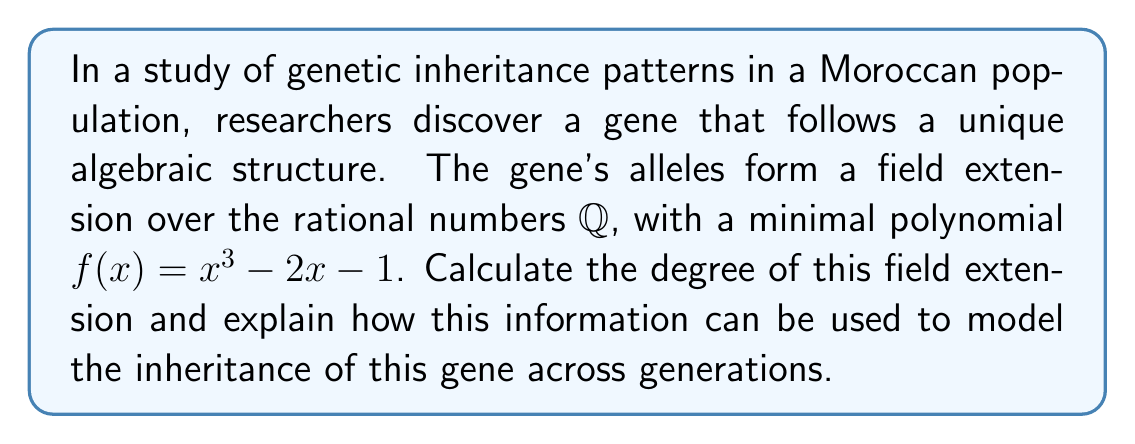Help me with this question. To solve this problem, we'll follow these steps:

1) The degree of a field extension is equal to the degree of the minimal polynomial of the extension. In this case, the minimal polynomial is:

   $f(x) = x^3 - 2x - 1$

2) The degree of this polynomial is 3.

3) Therefore, the degree of the field extension ℚ(α)/ℚ, where α is a root of f(x), is 3.

4) This means that [ℚ(α) : ℚ] = 3.

5) In genetic terms, this can be interpreted as follows:
   - The field extension degree of 3 suggests that this gene has three distinct allelic states.
   - These states correspond to the three roots of the polynomial in the algebraic closure of ℚ.

6) Modeling genetic inheritance:
   - Each individual inherits one allele from each parent.
   - The possible genotypes can be represented as elements of the field extension.
   - The degree 3 extension allows for more complex inheritance patterns than a simple dominant/recessive model.
   - Phenotypes could potentially have three distinct expressions, corresponding to the three field elements.

7) Across generations:
   - The inheritance pattern can be modeled using the field operations.
   - Addition in the field could represent gene combination.
   - Multiplication could represent interaction between alleles.
   - The structure of the field ensures that all operations result in valid genetic states within the model.

This algebraic model provides a sophisticated framework for tracking and predicting the inheritance of this gene, allowing for more nuanced analysis than traditional Mendelian genetics.
Answer: Degree: 3; Use: Models 3 allelic states, enables complex inheritance tracking 